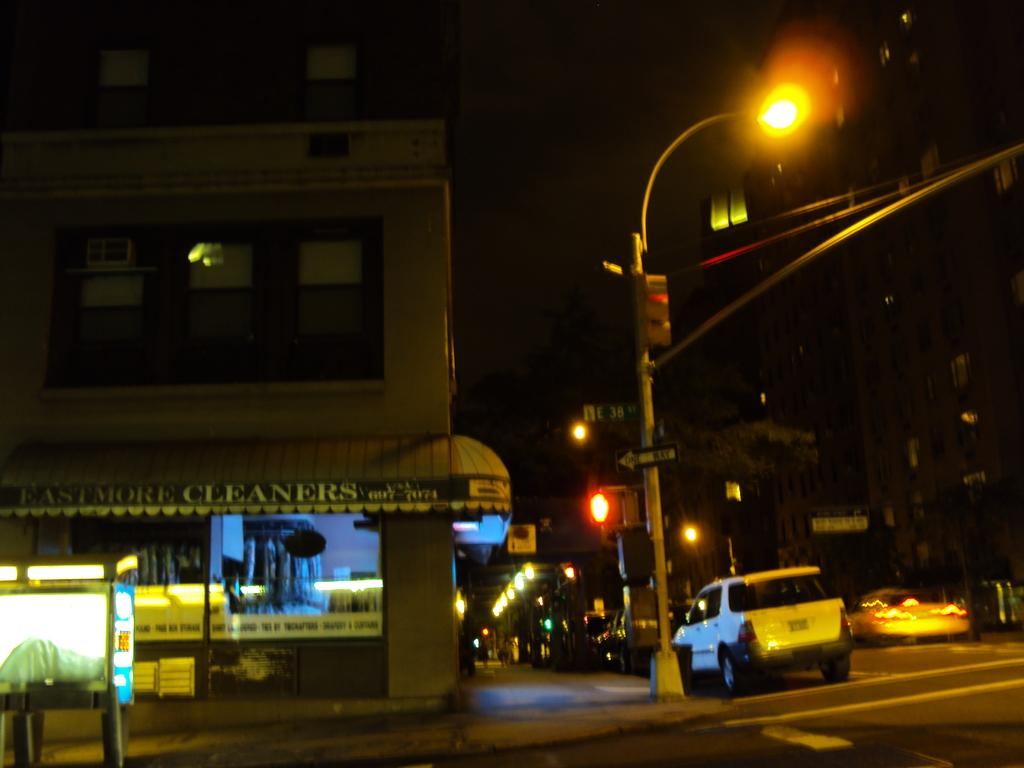<image>
Give a short and clear explanation of the subsequent image. A nighttime view of the Eastmore Cleaners with a white car parked outside. 